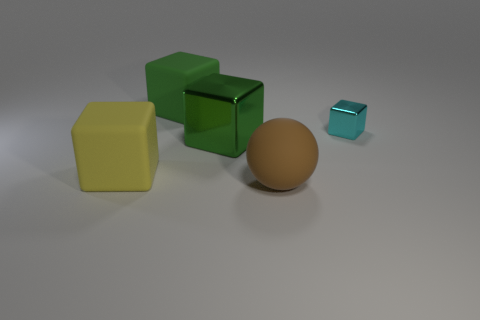What is the texture of the sphere? The sphere has a smooth and matte finish, with no discernible texture which suggests it feels soft to the touch, likely in contrast to the hard geometric shapes of the cubes. Could you guess the material of the sphere? Based on the image, the sphere looks like it could be made of a plastic or rubber-like material, given its smooth and non-reflective surface that suggests a softer and less rigid material than metal or glass. 